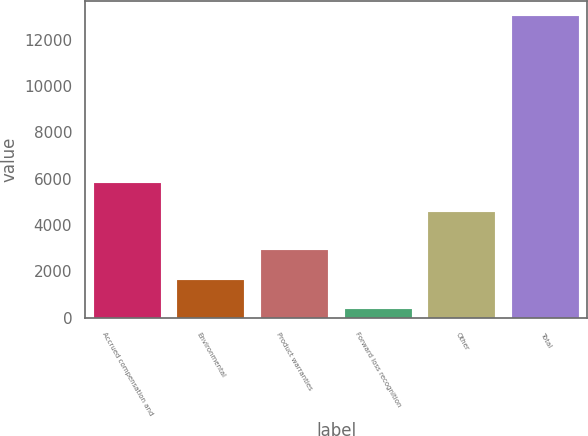Convert chart to OTSL. <chart><loc_0><loc_0><loc_500><loc_500><bar_chart><fcel>Accrued compensation and<fcel>Environmental<fcel>Product warranties<fcel>Forward loss recognition<fcel>Other<fcel>Total<nl><fcel>5817.8<fcel>1647.8<fcel>2908.6<fcel>387<fcel>4557<fcel>12995<nl></chart> 